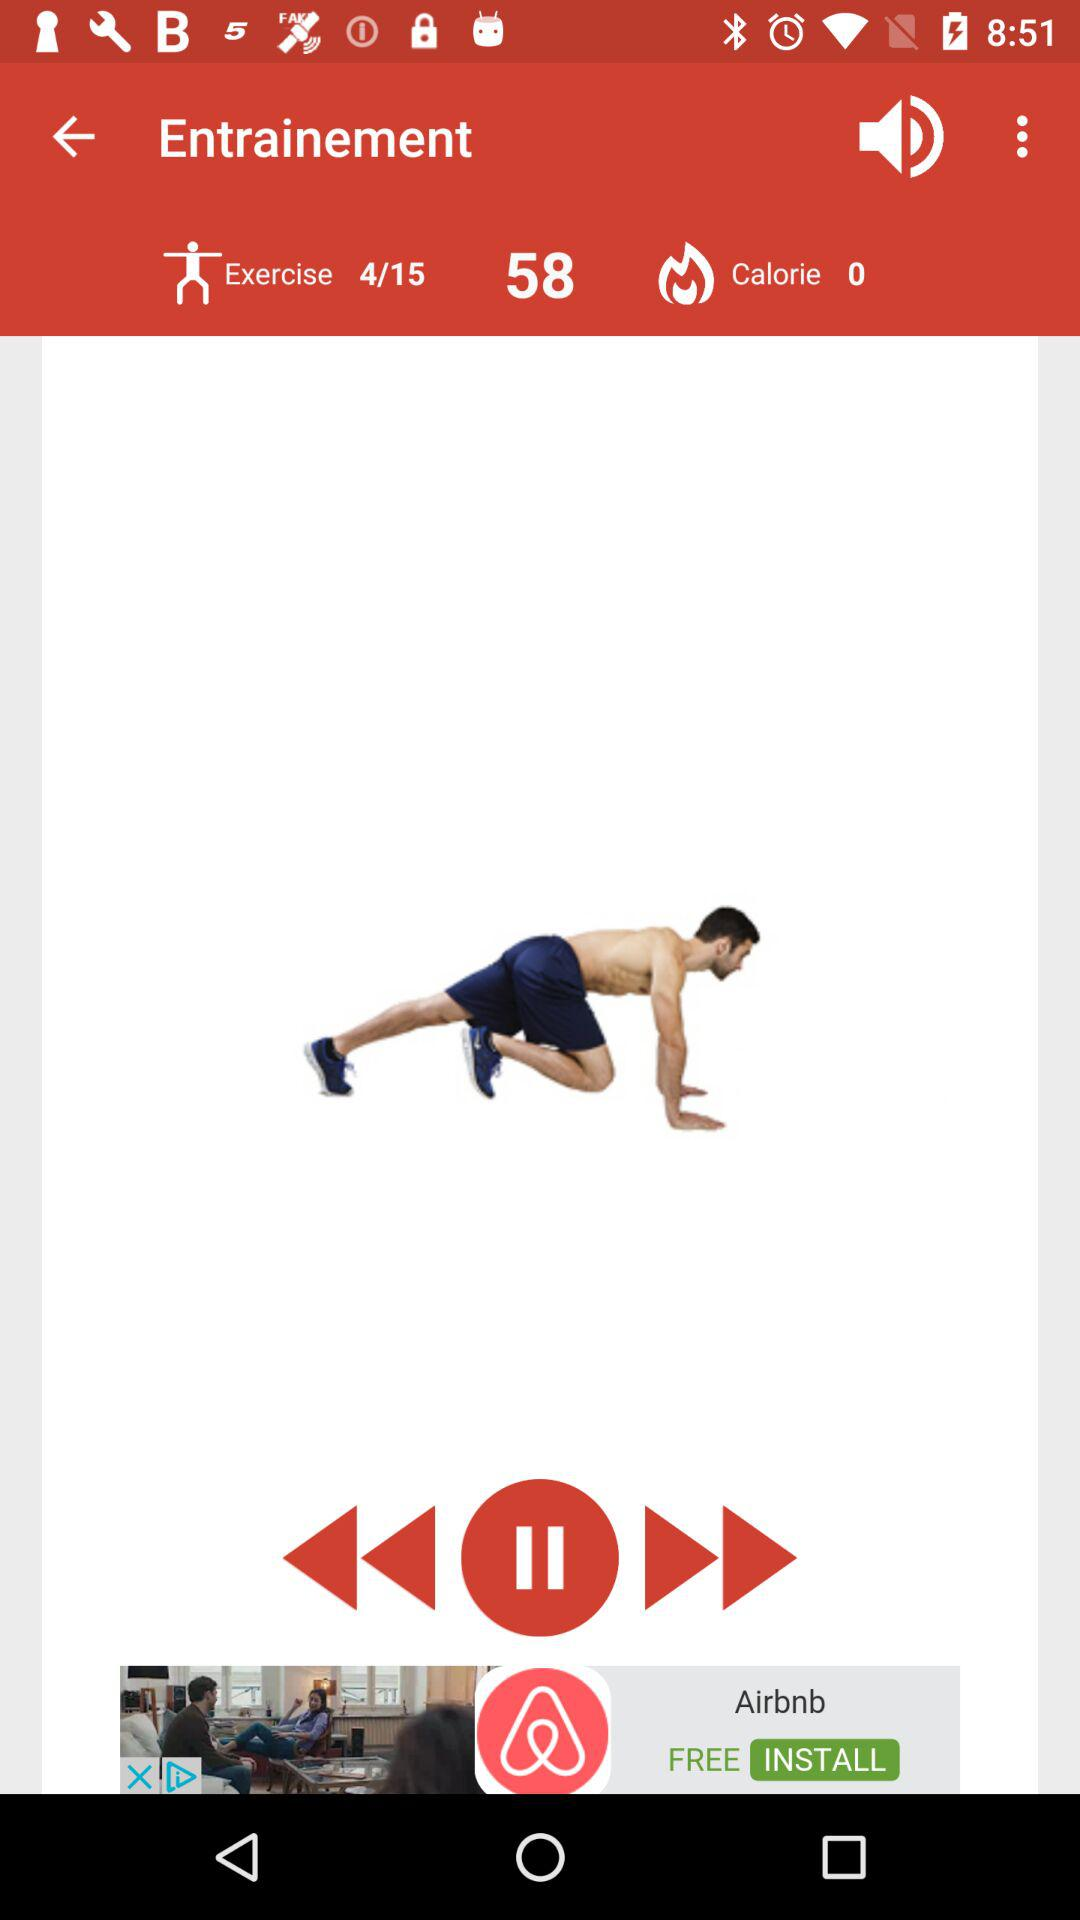How many calories are burned? There are 0 calories burned. 